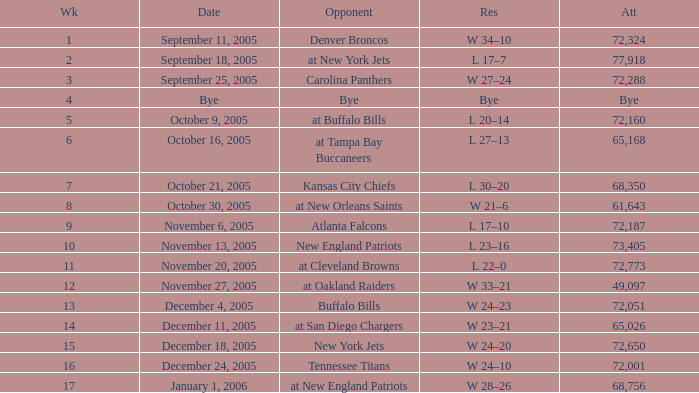On what Date was the Attendance 73,405? November 13, 2005. 